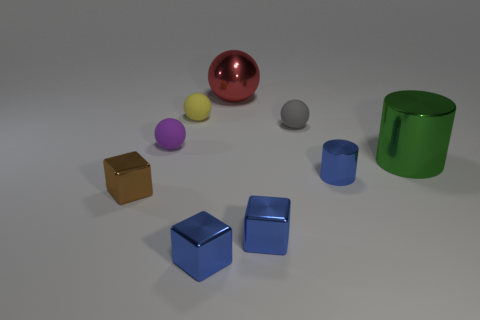Add 1 big gray metal cubes. How many objects exist? 10 Subtract all cubes. How many objects are left? 6 Subtract all large metallic objects. Subtract all small blue metal objects. How many objects are left? 4 Add 6 tiny metal things. How many tiny metal things are left? 10 Add 4 tiny yellow matte spheres. How many tiny yellow matte spheres exist? 5 Subtract 0 brown cylinders. How many objects are left? 9 